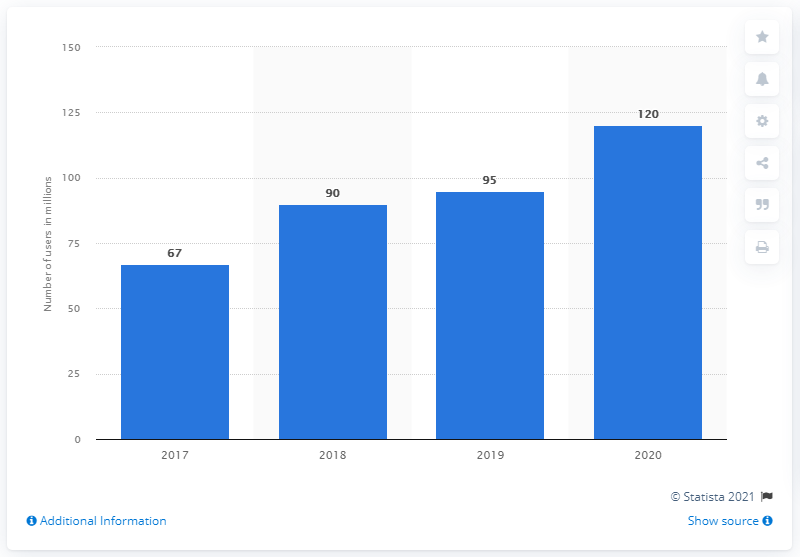Mention a couple of crucial points in this snapshot. In 2020, Steam had approximately 120 monthly active users. In the previous year, Steam had 95 million monthly active users. 